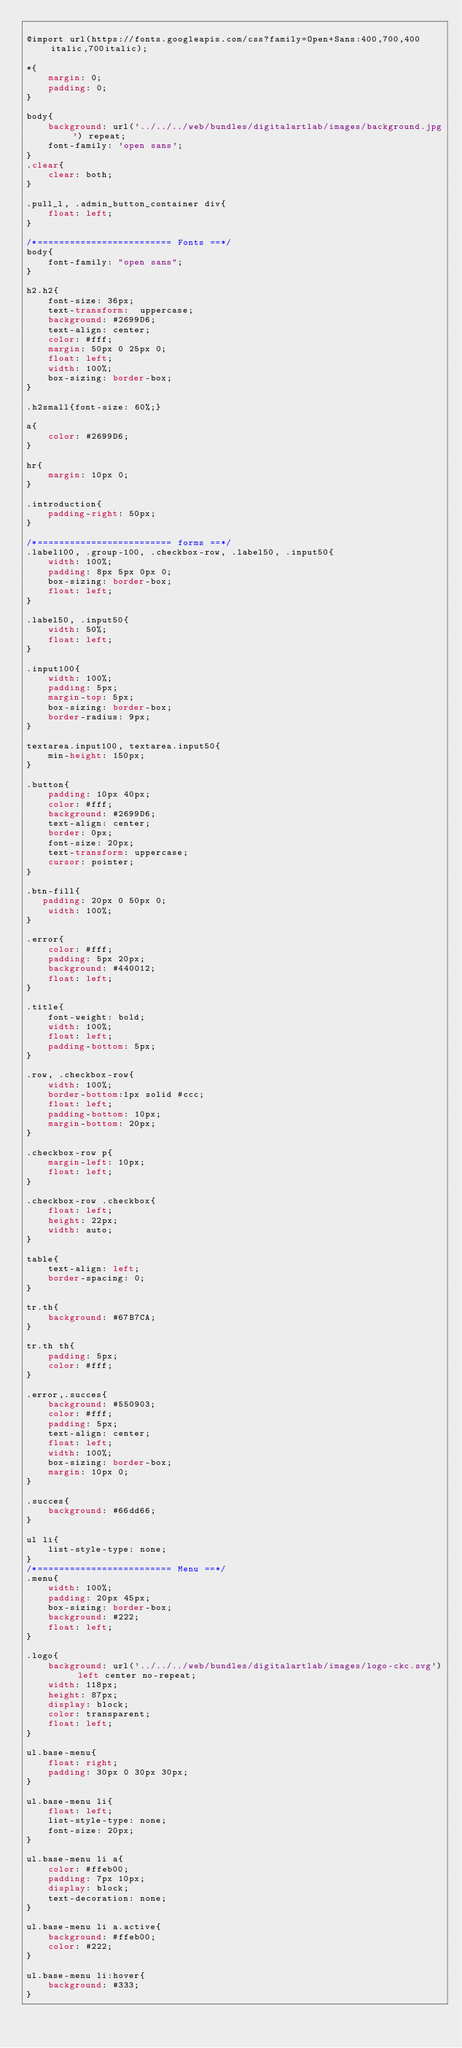Convert code to text. <code><loc_0><loc_0><loc_500><loc_500><_CSS_>
@import url(https://fonts.googleapis.com/css?family=Open+Sans:400,700,400italic,700italic);

*{
    margin: 0;
    padding: 0;
}

body{
    background: url('../../../web/bundles/digitalartlab/images/background.jpg') repeat;
    font-family: 'open sans';
}
.clear{
    clear: both;
}

.pull_l, .admin_button_container div{
    float: left;
}

/*========================= Fonts ==*/
body{
    font-family: "open sans";
}

h2.h2{
    font-size: 36px;
    text-transform:  uppercase;
    background: #2699D6;
    text-align: center;
    color: #fff;
    margin: 50px 0 25px 0;
    float: left;
    width: 100%;
    box-sizing: border-box;
}

.h2small{font-size: 60%;}

a{
    color: #2699D6;
}

hr{
    margin: 10px 0;
}

.introduction{
    padding-right: 50px;
}

/*========================= forms ==*/
.label100, .group-100, .checkbox-row, .label50, .input50{
    width: 100%;
    padding: 8px 5px 0px 0;
    box-sizing: border-box;
    float: left;
}

.label50, .input50{
    width: 50%;
    float: left;
}

.input100{
    width: 100%;
    padding: 5px;
    margin-top: 5px;
    box-sizing: border-box;
    border-radius: 9px;
}

textarea.input100, textarea.input50{
    min-height: 150px;
}

.button{
    padding: 10px 40px;
    color: #fff;
    background: #2699D6;
    text-align: center;
    border: 0px;
    font-size: 20px;
    text-transform: uppercase;
    cursor: pointer;
}

.btn-fill{
   padding: 20px 0 50px 0;
    width: 100%;
}

.error{
    color: #fff;
    padding: 5px 20px;
    background: #440012;
    float: left;
}

.title{
    font-weight: bold;
    width: 100%;
    float: left;
    padding-bottom: 5px;
}

.row, .checkbox-row{
    width: 100%;
    border-bottom:1px solid #ccc;
    float: left;
    padding-bottom: 10px;
    margin-bottom: 20px;
}

.checkbox-row p{
    margin-left: 10px;
    float: left;
}

.checkbox-row .checkbox{
    float: left;
    height: 22px;
    width: auto;
}

table{
    text-align: left;
    border-spacing: 0;
}

tr.th{
    background: #67B7CA;
}

tr.th th{
    padding: 5px;
    color: #fff;
}

.error,.succes{
    background: #550903;
    color: #fff;
    padding: 5px;
    text-align: center;
    float: left;
    width: 100%;
    box-sizing: border-box;
    margin: 10px 0;
}

.succes{
    background: #66dd66;
}

ul li{
    list-style-type: none;
}
/*========================= Menu ==*/
.menu{
    width: 100%;
    padding: 20px 45px;
    box-sizing: border-box;
    background: #222;
    float: left;
}

.logo{
    background: url('../../../web/bundles/digitalartlab/images/logo-ckc.svg') left center no-repeat;
    width: 118px;
    height: 87px;
    display: block;
    color: transparent;
    float: left;
}

ul.base-menu{
    float: right;
    padding: 30px 0 30px 30px;
}

ul.base-menu li{
    float: left;
    list-style-type: none;
    font-size: 20px;
}

ul.base-menu li a{
    color: #ffeb00;
    padding: 7px 10px;
    display: block;
    text-decoration: none;
}

ul.base-menu li a.active{
    background: #ffeb00;
    color: #222;
}

ul.base-menu li:hover{
    background: #333;
}
</code> 